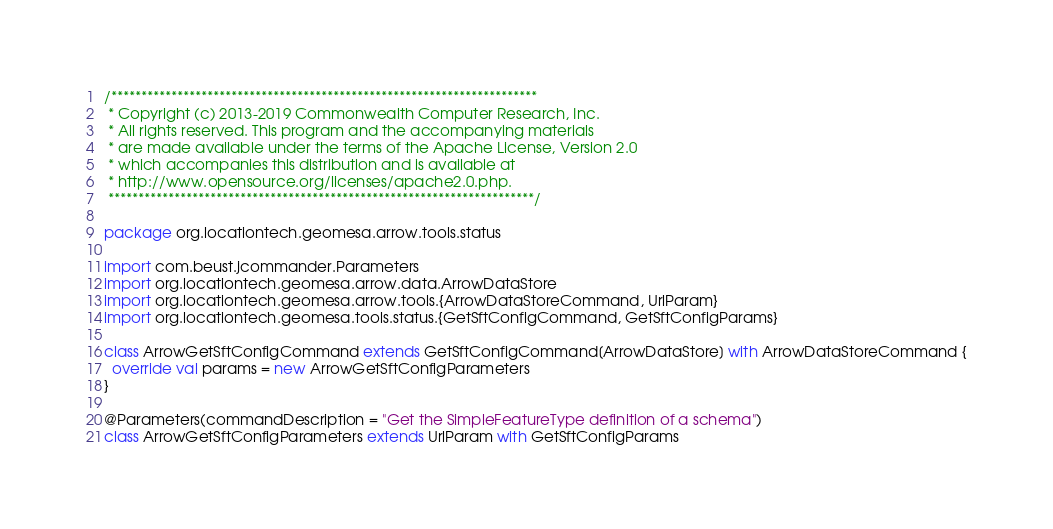<code> <loc_0><loc_0><loc_500><loc_500><_Scala_>/***********************************************************************
 * Copyright (c) 2013-2019 Commonwealth Computer Research, Inc.
 * All rights reserved. This program and the accompanying materials
 * are made available under the terms of the Apache License, Version 2.0
 * which accompanies this distribution and is available at
 * http://www.opensource.org/licenses/apache2.0.php.
 ***********************************************************************/

package org.locationtech.geomesa.arrow.tools.status

import com.beust.jcommander.Parameters
import org.locationtech.geomesa.arrow.data.ArrowDataStore
import org.locationtech.geomesa.arrow.tools.{ArrowDataStoreCommand, UrlParam}
import org.locationtech.geomesa.tools.status.{GetSftConfigCommand, GetSftConfigParams}

class ArrowGetSftConfigCommand extends GetSftConfigCommand[ArrowDataStore] with ArrowDataStoreCommand {
  override val params = new ArrowGetSftConfigParameters
}

@Parameters(commandDescription = "Get the SimpleFeatureType definition of a schema")
class ArrowGetSftConfigParameters extends UrlParam with GetSftConfigParams
</code> 